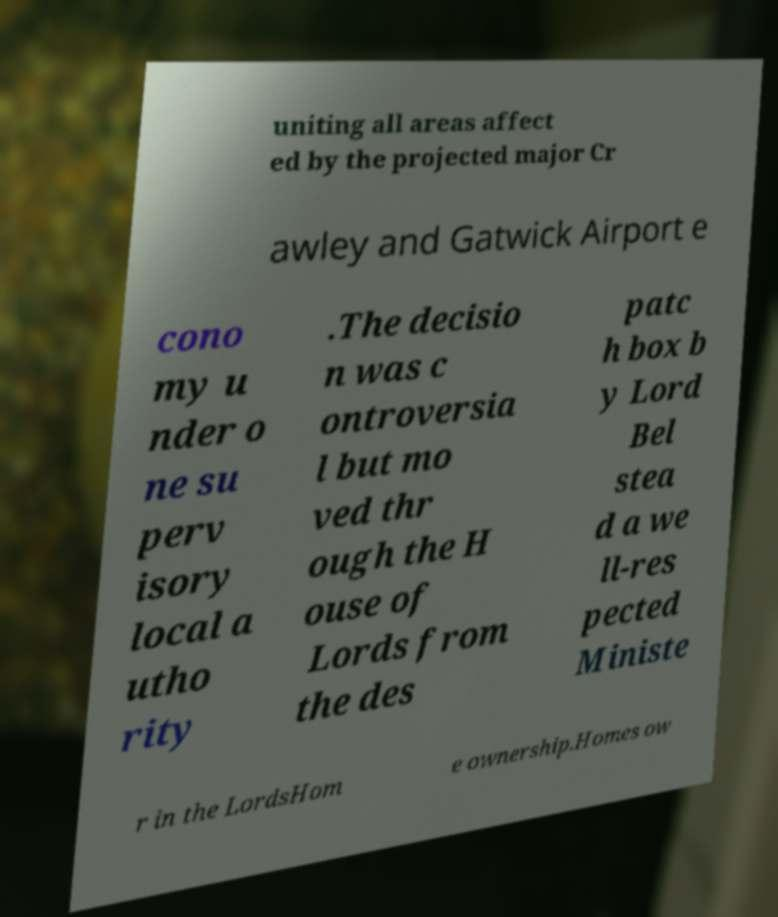Could you assist in decoding the text presented in this image and type it out clearly? uniting all areas affect ed by the projected major Cr awley and Gatwick Airport e cono my u nder o ne su perv isory local a utho rity .The decisio n was c ontroversia l but mo ved thr ough the H ouse of Lords from the des patc h box b y Lord Bel stea d a we ll-res pected Ministe r in the LordsHom e ownership.Homes ow 